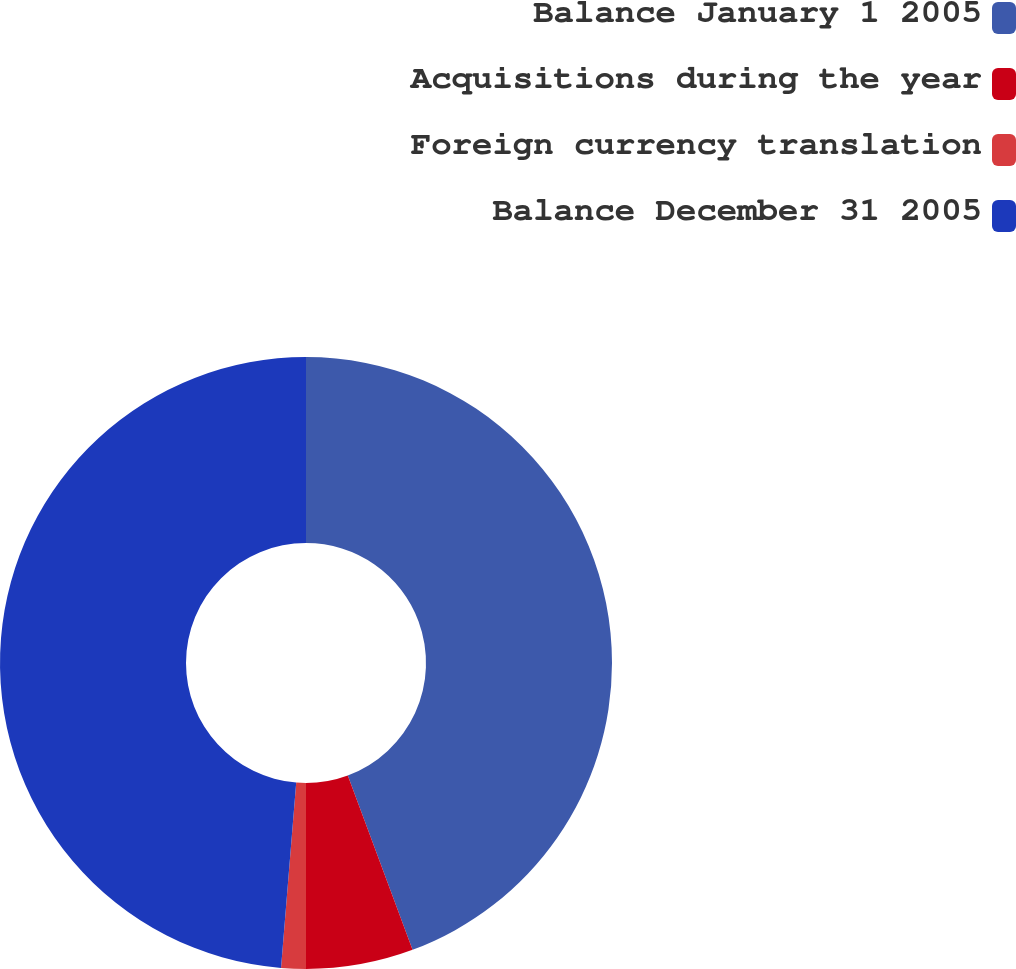<chart> <loc_0><loc_0><loc_500><loc_500><pie_chart><fcel>Balance January 1 2005<fcel>Acquisitions during the year<fcel>Foreign currency translation<fcel>Balance December 31 2005<nl><fcel>44.34%<fcel>5.66%<fcel>1.3%<fcel>48.7%<nl></chart> 